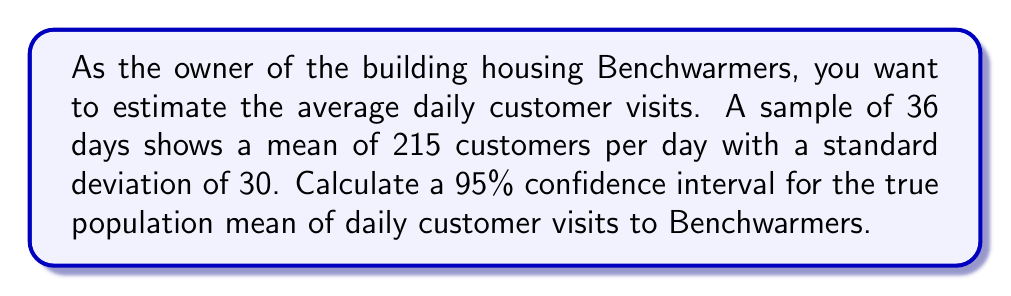Solve this math problem. To calculate the confidence interval, we'll use the formula:

$$ \bar{x} \pm t_{\alpha/2} \cdot \frac{s}{\sqrt{n}} $$

Where:
$\bar{x}$ = sample mean = 215
$s$ = sample standard deviation = 30
$n$ = sample size = 36
$t_{\alpha/2}$ = t-value for 95% confidence level with 35 degrees of freedom

Steps:
1) Find $t_{\alpha/2}$:
   For 95% confidence and 35 df, $t_{\alpha/2} = 2.030$ (from t-distribution table)

2) Calculate standard error:
   $SE = \frac{s}{\sqrt{n}} = \frac{30}{\sqrt{36}} = 5$

3) Calculate margin of error:
   $ME = t_{\alpha/2} \cdot SE = 2.030 \cdot 5 = 10.15$

4) Calculate confidence interval:
   Lower bound: $215 - 10.15 = 204.85$
   Upper bound: $215 + 10.15 = 225.15$

Therefore, we are 95% confident that the true population mean of daily customer visits to Benchwarmers is between 204.85 and 225.15.
Answer: (204.85, 225.15) 